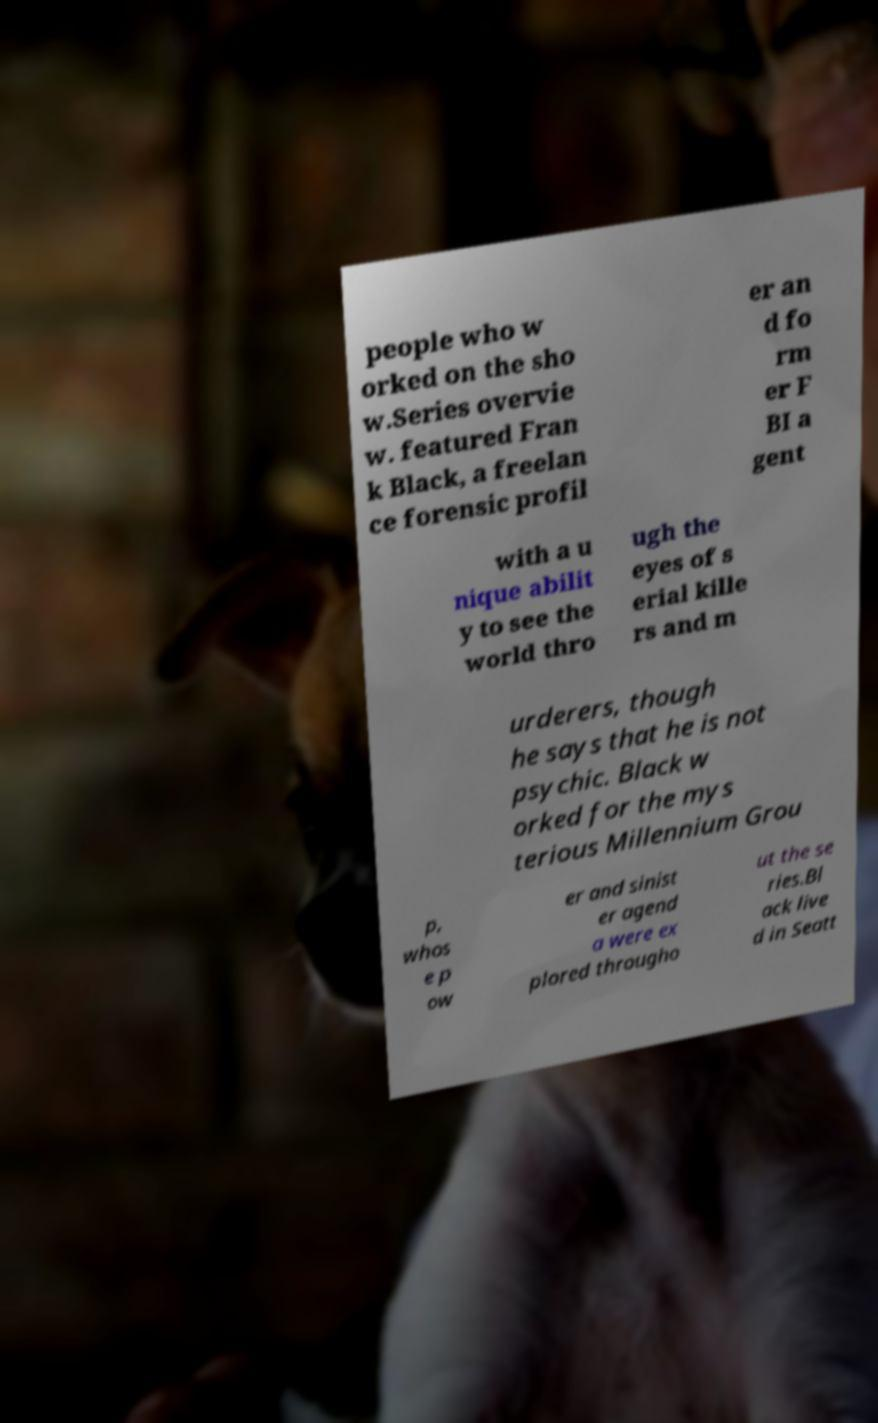I need the written content from this picture converted into text. Can you do that? people who w orked on the sho w.Series overvie w. featured Fran k Black, a freelan ce forensic profil er an d fo rm er F BI a gent with a u nique abilit y to see the world thro ugh the eyes of s erial kille rs and m urderers, though he says that he is not psychic. Black w orked for the mys terious Millennium Grou p, whos e p ow er and sinist er agend a were ex plored througho ut the se ries.Bl ack live d in Seatt 